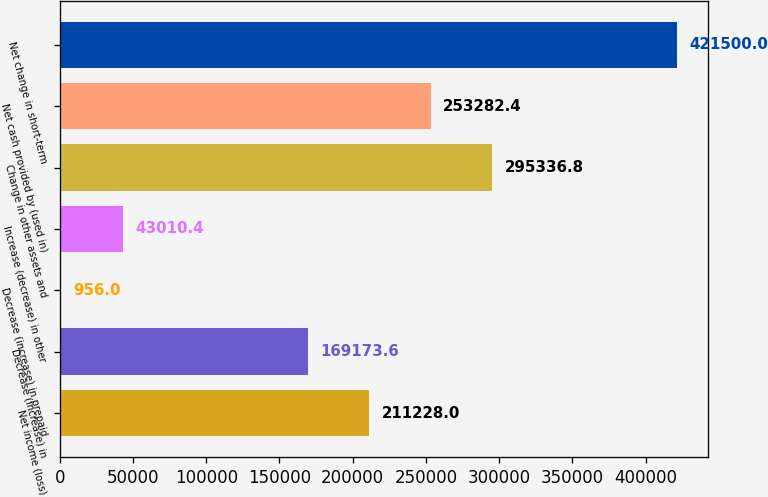Convert chart to OTSL. <chart><loc_0><loc_0><loc_500><loc_500><bar_chart><fcel>Net income (loss)<fcel>Decrease (increase) in<fcel>Decrease (increase) in prepaid<fcel>Increase (decrease) in other<fcel>Change in other assets and<fcel>Net cash provided by (used in)<fcel>Net change in short-term<nl><fcel>211228<fcel>169174<fcel>956<fcel>43010.4<fcel>295337<fcel>253282<fcel>421500<nl></chart> 